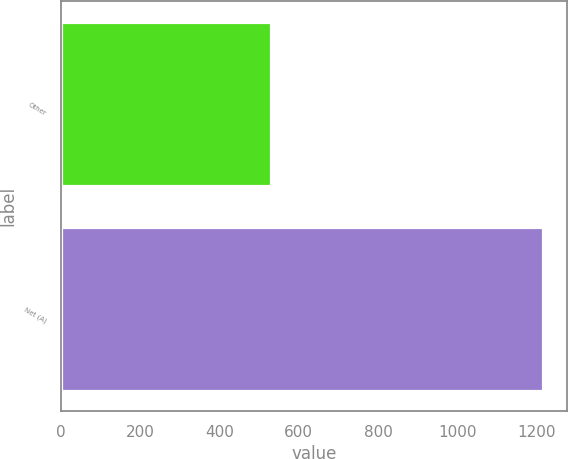<chart> <loc_0><loc_0><loc_500><loc_500><bar_chart><fcel>Other<fcel>Net (A)<nl><fcel>531<fcel>1216<nl></chart> 